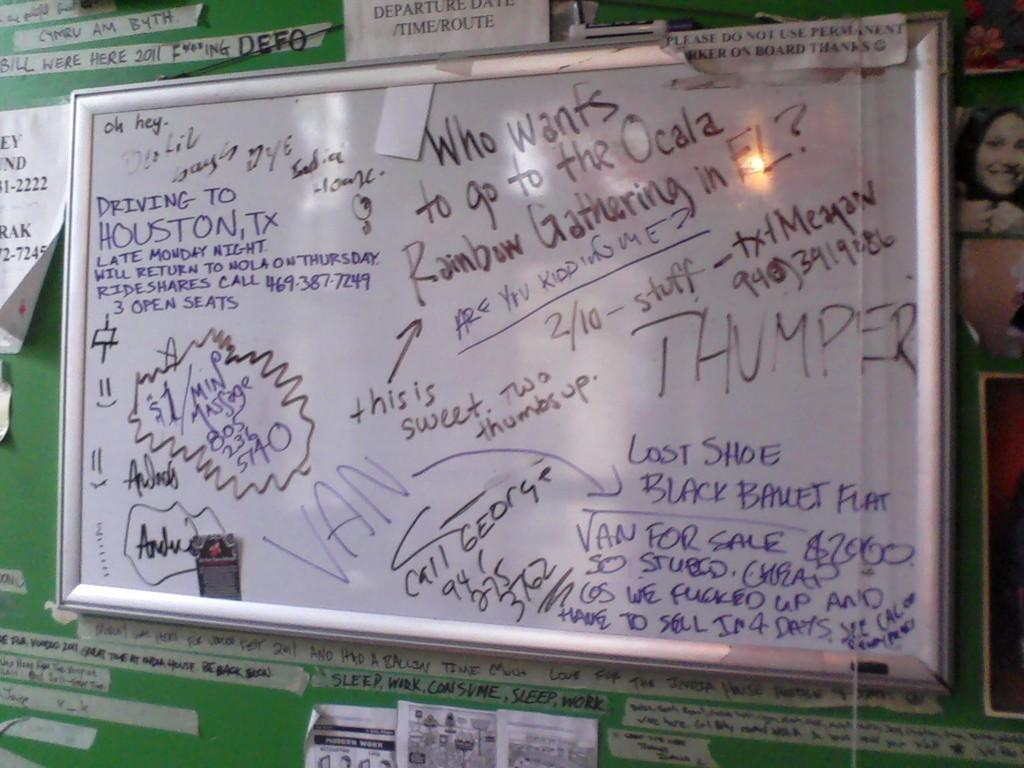What is on the board that is visible in the image? There is a board with writing in the image. What can be seen on the wall in the background? There is a green wall with posters in the background. What is on the right side of the image? There is an image of a lady on the right side of the image. What type of beef is being cooked in the image? There is no beef present in the image. What musical instrument is being played in the image? There is no musical instrument being played in the image. 